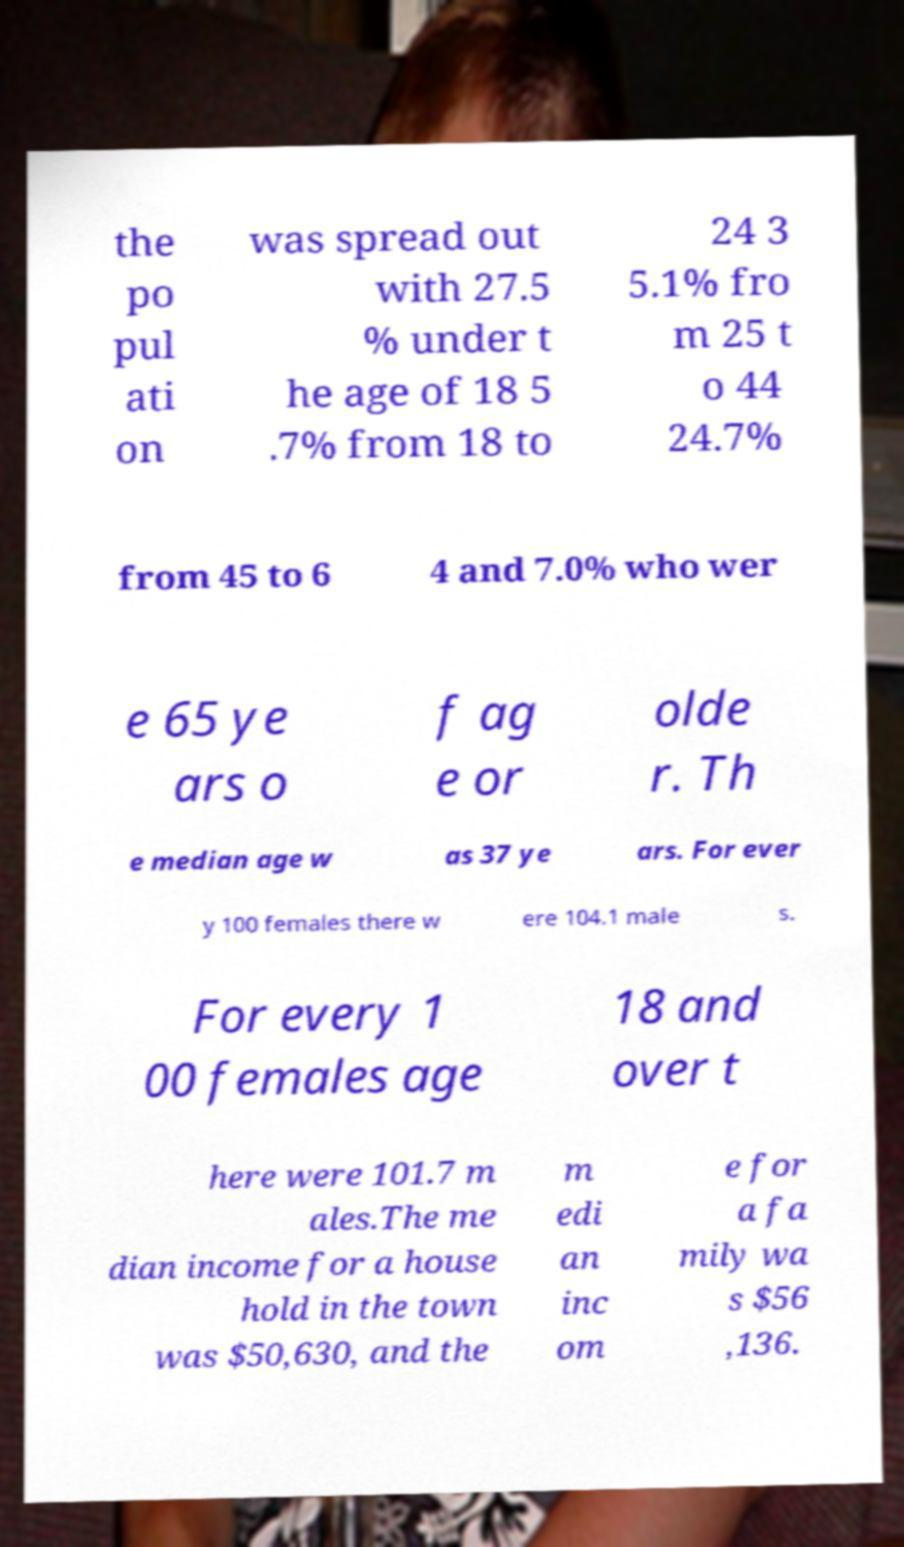Please identify and transcribe the text found in this image. the po pul ati on was spread out with 27.5 % under t he age of 18 5 .7% from 18 to 24 3 5.1% fro m 25 t o 44 24.7% from 45 to 6 4 and 7.0% who wer e 65 ye ars o f ag e or olde r. Th e median age w as 37 ye ars. For ever y 100 females there w ere 104.1 male s. For every 1 00 females age 18 and over t here were 101.7 m ales.The me dian income for a house hold in the town was $50,630, and the m edi an inc om e for a fa mily wa s $56 ,136. 